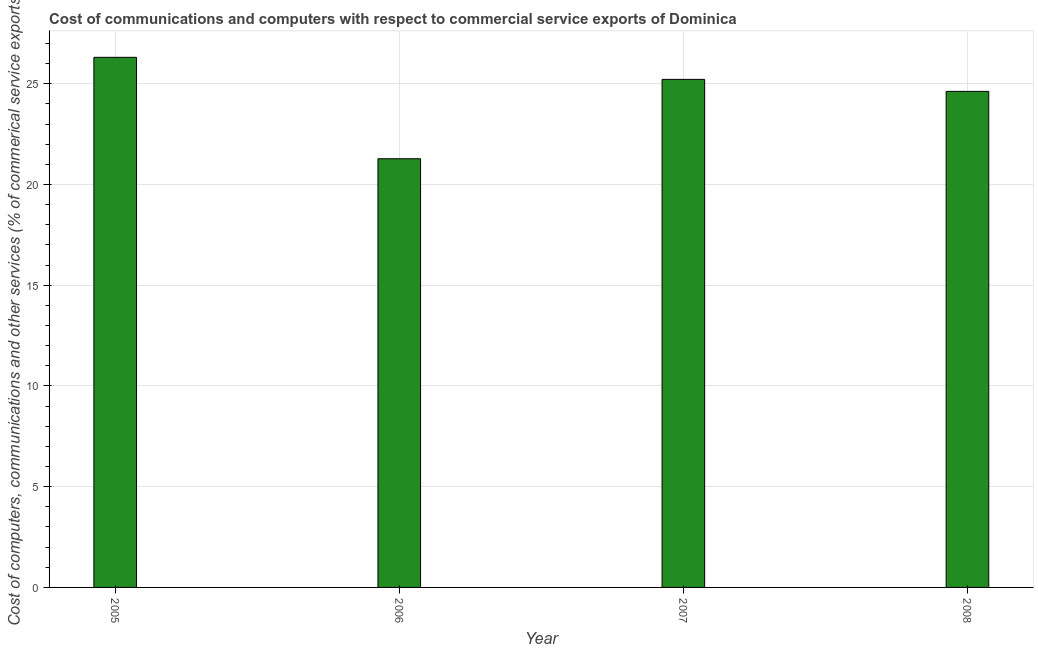Does the graph contain any zero values?
Provide a succinct answer. No. Does the graph contain grids?
Provide a short and direct response. Yes. What is the title of the graph?
Your answer should be compact. Cost of communications and computers with respect to commercial service exports of Dominica. What is the label or title of the Y-axis?
Your response must be concise. Cost of computers, communications and other services (% of commerical service exports). What is the  computer and other services in 2005?
Provide a succinct answer. 26.31. Across all years, what is the maximum  computer and other services?
Ensure brevity in your answer.  26.31. Across all years, what is the minimum  computer and other services?
Provide a short and direct response. 21.28. What is the sum of the cost of communications?
Provide a succinct answer. 97.44. What is the difference between the  computer and other services in 2005 and 2008?
Your answer should be very brief. 1.69. What is the average cost of communications per year?
Your response must be concise. 24.36. What is the median cost of communications?
Keep it short and to the point. 24.92. Do a majority of the years between 2008 and 2006 (inclusive) have  computer and other services greater than 2 %?
Your response must be concise. Yes. What is the ratio of the  computer and other services in 2005 to that in 2008?
Your answer should be very brief. 1.07. Is the cost of communications in 2006 less than that in 2008?
Provide a short and direct response. Yes. What is the difference between the highest and the second highest  computer and other services?
Provide a short and direct response. 1.09. Is the sum of the cost of communications in 2005 and 2008 greater than the maximum cost of communications across all years?
Offer a very short reply. Yes. What is the difference between the highest and the lowest cost of communications?
Your answer should be very brief. 5.03. How many bars are there?
Provide a short and direct response. 4. What is the difference between two consecutive major ticks on the Y-axis?
Offer a terse response. 5. What is the Cost of computers, communications and other services (% of commerical service exports) of 2005?
Keep it short and to the point. 26.31. What is the Cost of computers, communications and other services (% of commerical service exports) in 2006?
Ensure brevity in your answer.  21.28. What is the Cost of computers, communications and other services (% of commerical service exports) in 2007?
Your response must be concise. 25.22. What is the Cost of computers, communications and other services (% of commerical service exports) of 2008?
Offer a terse response. 24.62. What is the difference between the Cost of computers, communications and other services (% of commerical service exports) in 2005 and 2006?
Give a very brief answer. 5.03. What is the difference between the Cost of computers, communications and other services (% of commerical service exports) in 2005 and 2007?
Keep it short and to the point. 1.09. What is the difference between the Cost of computers, communications and other services (% of commerical service exports) in 2005 and 2008?
Your answer should be very brief. 1.69. What is the difference between the Cost of computers, communications and other services (% of commerical service exports) in 2006 and 2007?
Provide a short and direct response. -3.94. What is the difference between the Cost of computers, communications and other services (% of commerical service exports) in 2006 and 2008?
Your answer should be compact. -3.34. What is the difference between the Cost of computers, communications and other services (% of commerical service exports) in 2007 and 2008?
Your answer should be very brief. 0.6. What is the ratio of the Cost of computers, communications and other services (% of commerical service exports) in 2005 to that in 2006?
Your answer should be very brief. 1.24. What is the ratio of the Cost of computers, communications and other services (% of commerical service exports) in 2005 to that in 2007?
Make the answer very short. 1.04. What is the ratio of the Cost of computers, communications and other services (% of commerical service exports) in 2005 to that in 2008?
Keep it short and to the point. 1.07. What is the ratio of the Cost of computers, communications and other services (% of commerical service exports) in 2006 to that in 2007?
Give a very brief answer. 0.84. What is the ratio of the Cost of computers, communications and other services (% of commerical service exports) in 2006 to that in 2008?
Your response must be concise. 0.86. 